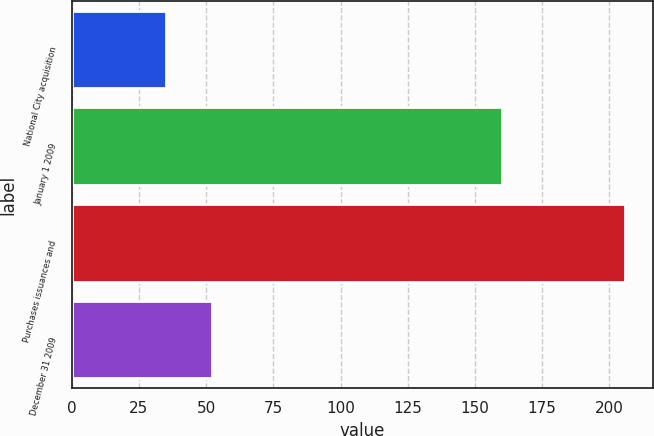Convert chart to OTSL. <chart><loc_0><loc_0><loc_500><loc_500><bar_chart><fcel>National City acquisition<fcel>January 1 2009<fcel>Purchases issuances and<fcel>December 31 2009<nl><fcel>35<fcel>160<fcel>206<fcel>52.1<nl></chart> 